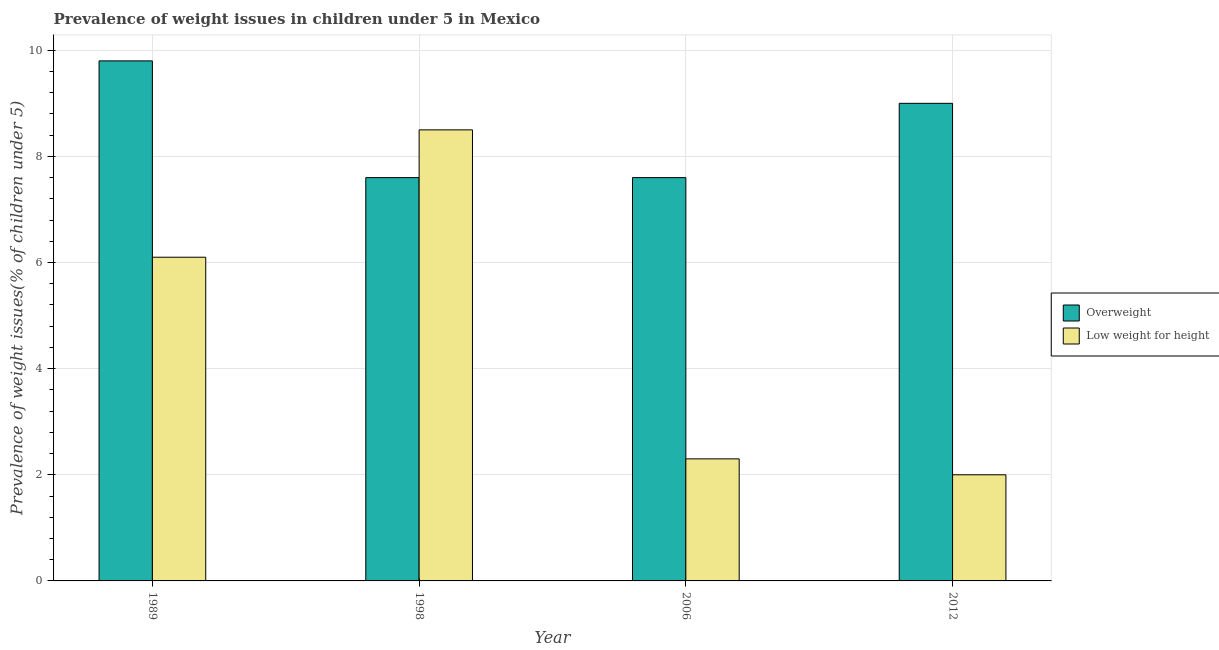How many groups of bars are there?
Your response must be concise. 4. Are the number of bars per tick equal to the number of legend labels?
Your answer should be compact. Yes. How many bars are there on the 1st tick from the right?
Offer a terse response. 2. What is the percentage of overweight children in 1998?
Provide a short and direct response. 7.6. Across all years, what is the minimum percentage of overweight children?
Your answer should be very brief. 7.6. In which year was the percentage of overweight children minimum?
Provide a short and direct response. 1998. What is the total percentage of overweight children in the graph?
Ensure brevity in your answer.  34. What is the difference between the percentage of overweight children in 1989 and the percentage of underweight children in 1998?
Offer a very short reply. 2.2. What is the ratio of the percentage of overweight children in 1998 to that in 2012?
Your response must be concise. 0.84. What is the difference between the highest and the second highest percentage of underweight children?
Provide a succinct answer. 2.4. What is the difference between the highest and the lowest percentage of overweight children?
Provide a succinct answer. 2.2. Is the sum of the percentage of underweight children in 2006 and 2012 greater than the maximum percentage of overweight children across all years?
Provide a short and direct response. No. What does the 1st bar from the left in 2012 represents?
Your answer should be very brief. Overweight. What does the 2nd bar from the right in 2012 represents?
Your response must be concise. Overweight. How many bars are there?
Your response must be concise. 8. Are all the bars in the graph horizontal?
Your answer should be very brief. No. Does the graph contain any zero values?
Your answer should be very brief. No. How are the legend labels stacked?
Your response must be concise. Vertical. What is the title of the graph?
Your answer should be very brief. Prevalence of weight issues in children under 5 in Mexico. What is the label or title of the Y-axis?
Keep it short and to the point. Prevalence of weight issues(% of children under 5). What is the Prevalence of weight issues(% of children under 5) in Overweight in 1989?
Your answer should be very brief. 9.8. What is the Prevalence of weight issues(% of children under 5) in Low weight for height in 1989?
Your response must be concise. 6.1. What is the Prevalence of weight issues(% of children under 5) of Overweight in 1998?
Your response must be concise. 7.6. What is the Prevalence of weight issues(% of children under 5) of Overweight in 2006?
Your answer should be compact. 7.6. What is the Prevalence of weight issues(% of children under 5) in Low weight for height in 2006?
Offer a very short reply. 2.3. Across all years, what is the maximum Prevalence of weight issues(% of children under 5) in Overweight?
Your answer should be very brief. 9.8. Across all years, what is the maximum Prevalence of weight issues(% of children under 5) in Low weight for height?
Keep it short and to the point. 8.5. Across all years, what is the minimum Prevalence of weight issues(% of children under 5) of Overweight?
Ensure brevity in your answer.  7.6. What is the total Prevalence of weight issues(% of children under 5) of Low weight for height in the graph?
Your response must be concise. 18.9. What is the difference between the Prevalence of weight issues(% of children under 5) of Low weight for height in 1989 and that in 2006?
Give a very brief answer. 3.8. What is the difference between the Prevalence of weight issues(% of children under 5) in Low weight for height in 1989 and that in 2012?
Provide a succinct answer. 4.1. What is the difference between the Prevalence of weight issues(% of children under 5) in Overweight in 1998 and that in 2012?
Your answer should be very brief. -1.4. What is the difference between the Prevalence of weight issues(% of children under 5) in Low weight for height in 1998 and that in 2012?
Make the answer very short. 6.5. What is the difference between the Prevalence of weight issues(% of children under 5) of Overweight in 2006 and that in 2012?
Provide a short and direct response. -1.4. What is the difference between the Prevalence of weight issues(% of children under 5) of Low weight for height in 2006 and that in 2012?
Provide a succinct answer. 0.3. What is the difference between the Prevalence of weight issues(% of children under 5) of Overweight in 1989 and the Prevalence of weight issues(% of children under 5) of Low weight for height in 1998?
Give a very brief answer. 1.3. What is the difference between the Prevalence of weight issues(% of children under 5) in Overweight in 1989 and the Prevalence of weight issues(% of children under 5) in Low weight for height in 2006?
Provide a short and direct response. 7.5. What is the difference between the Prevalence of weight issues(% of children under 5) in Overweight in 1989 and the Prevalence of weight issues(% of children under 5) in Low weight for height in 2012?
Your answer should be very brief. 7.8. What is the difference between the Prevalence of weight issues(% of children under 5) in Overweight in 1998 and the Prevalence of weight issues(% of children under 5) in Low weight for height in 2006?
Provide a succinct answer. 5.3. What is the difference between the Prevalence of weight issues(% of children under 5) of Overweight in 1998 and the Prevalence of weight issues(% of children under 5) of Low weight for height in 2012?
Provide a short and direct response. 5.6. What is the difference between the Prevalence of weight issues(% of children under 5) of Overweight in 2006 and the Prevalence of weight issues(% of children under 5) of Low weight for height in 2012?
Offer a terse response. 5.6. What is the average Prevalence of weight issues(% of children under 5) in Low weight for height per year?
Your response must be concise. 4.72. In the year 1998, what is the difference between the Prevalence of weight issues(% of children under 5) of Overweight and Prevalence of weight issues(% of children under 5) of Low weight for height?
Provide a short and direct response. -0.9. In the year 2006, what is the difference between the Prevalence of weight issues(% of children under 5) in Overweight and Prevalence of weight issues(% of children under 5) in Low weight for height?
Offer a very short reply. 5.3. What is the ratio of the Prevalence of weight issues(% of children under 5) of Overweight in 1989 to that in 1998?
Your response must be concise. 1.29. What is the ratio of the Prevalence of weight issues(% of children under 5) of Low weight for height in 1989 to that in 1998?
Give a very brief answer. 0.72. What is the ratio of the Prevalence of weight issues(% of children under 5) in Overweight in 1989 to that in 2006?
Give a very brief answer. 1.29. What is the ratio of the Prevalence of weight issues(% of children under 5) of Low weight for height in 1989 to that in 2006?
Provide a short and direct response. 2.65. What is the ratio of the Prevalence of weight issues(% of children under 5) of Overweight in 1989 to that in 2012?
Offer a very short reply. 1.09. What is the ratio of the Prevalence of weight issues(% of children under 5) of Low weight for height in 1989 to that in 2012?
Make the answer very short. 3.05. What is the ratio of the Prevalence of weight issues(% of children under 5) of Low weight for height in 1998 to that in 2006?
Give a very brief answer. 3.7. What is the ratio of the Prevalence of weight issues(% of children under 5) of Overweight in 1998 to that in 2012?
Offer a very short reply. 0.84. What is the ratio of the Prevalence of weight issues(% of children under 5) in Low weight for height in 1998 to that in 2012?
Your answer should be compact. 4.25. What is the ratio of the Prevalence of weight issues(% of children under 5) of Overweight in 2006 to that in 2012?
Your response must be concise. 0.84. What is the ratio of the Prevalence of weight issues(% of children under 5) in Low weight for height in 2006 to that in 2012?
Provide a succinct answer. 1.15. What is the difference between the highest and the second highest Prevalence of weight issues(% of children under 5) in Low weight for height?
Provide a short and direct response. 2.4. What is the difference between the highest and the lowest Prevalence of weight issues(% of children under 5) of Overweight?
Ensure brevity in your answer.  2.2. What is the difference between the highest and the lowest Prevalence of weight issues(% of children under 5) in Low weight for height?
Offer a very short reply. 6.5. 